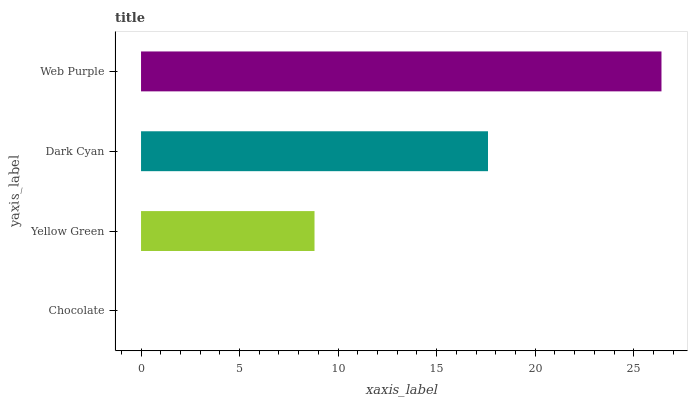Is Chocolate the minimum?
Answer yes or no. Yes. Is Web Purple the maximum?
Answer yes or no. Yes. Is Yellow Green the minimum?
Answer yes or no. No. Is Yellow Green the maximum?
Answer yes or no. No. Is Yellow Green greater than Chocolate?
Answer yes or no. Yes. Is Chocolate less than Yellow Green?
Answer yes or no. Yes. Is Chocolate greater than Yellow Green?
Answer yes or no. No. Is Yellow Green less than Chocolate?
Answer yes or no. No. Is Dark Cyan the high median?
Answer yes or no. Yes. Is Yellow Green the low median?
Answer yes or no. Yes. Is Chocolate the high median?
Answer yes or no. No. Is Dark Cyan the low median?
Answer yes or no. No. 